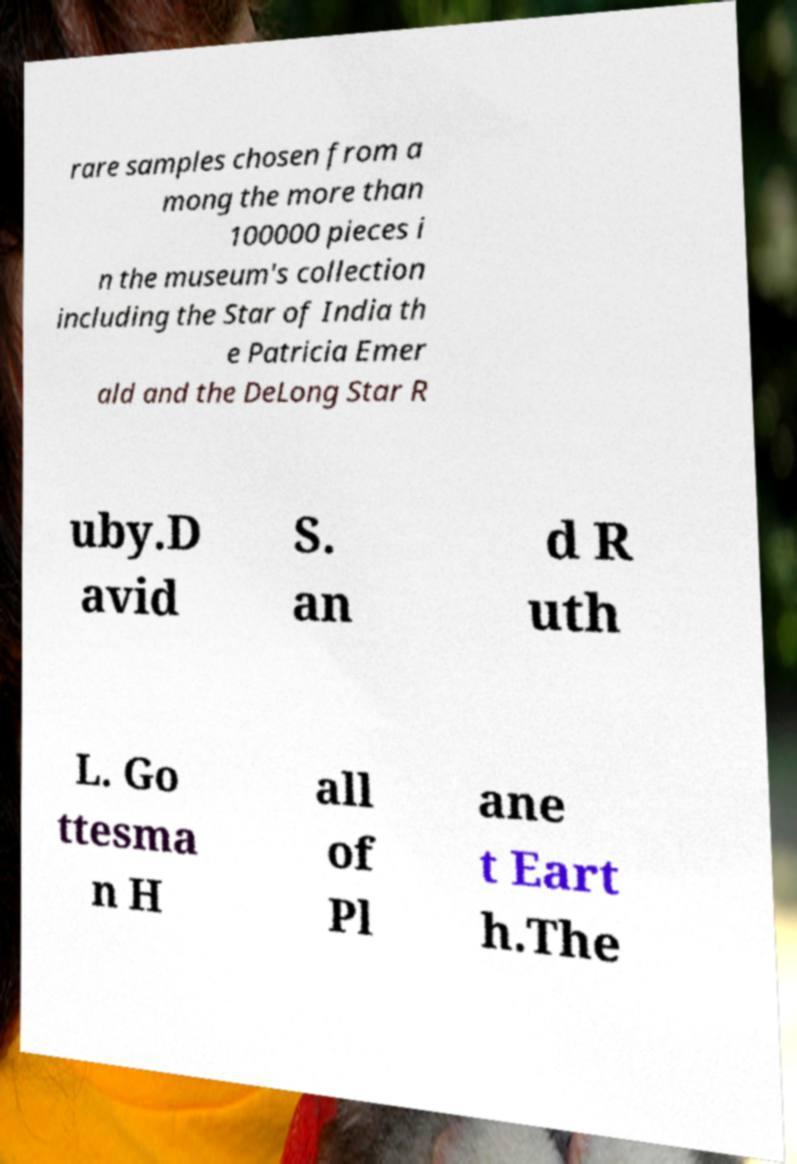For documentation purposes, I need the text within this image transcribed. Could you provide that? rare samples chosen from a mong the more than 100000 pieces i n the museum's collection including the Star of India th e Patricia Emer ald and the DeLong Star R uby.D avid S. an d R uth L. Go ttesma n H all of Pl ane t Eart h.The 